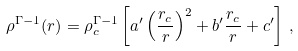<formula> <loc_0><loc_0><loc_500><loc_500>\rho ^ { \Gamma - 1 } ( r ) = \rho _ { c } ^ { \Gamma - 1 } \left [ a ^ { \prime } \left ( \frac { r _ { c } } { r } \right ) ^ { 2 } + b ^ { \prime } \frac { r _ { c } } { r } + c ^ { \prime } \right ] \, ,</formula> 